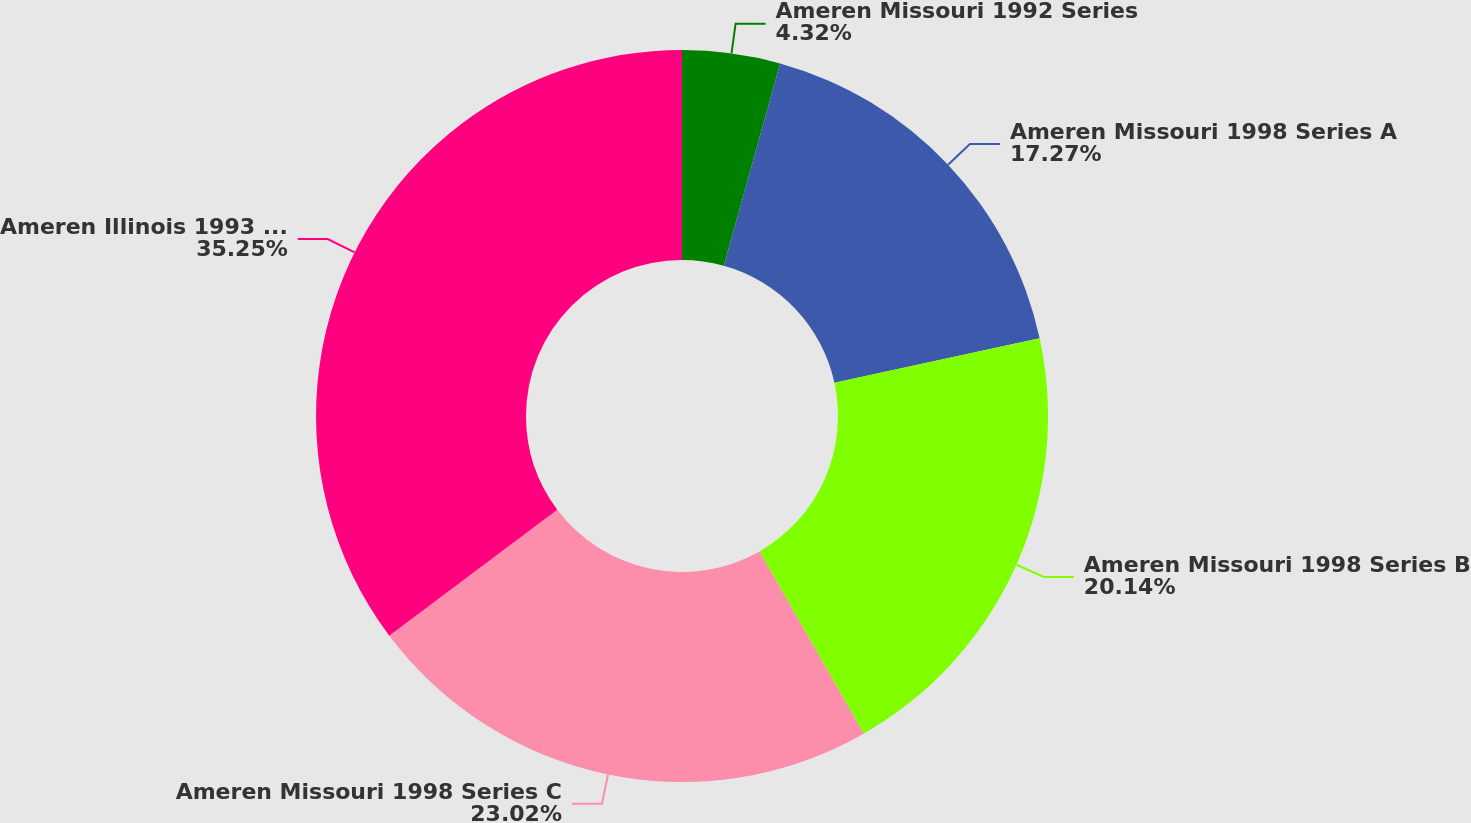<chart> <loc_0><loc_0><loc_500><loc_500><pie_chart><fcel>Ameren Missouri 1992 Series<fcel>Ameren Missouri 1998 Series A<fcel>Ameren Missouri 1998 Series B<fcel>Ameren Missouri 1998 Series C<fcel>Ameren Illinois 1993 Series<nl><fcel>4.32%<fcel>17.27%<fcel>20.14%<fcel>23.02%<fcel>35.25%<nl></chart> 